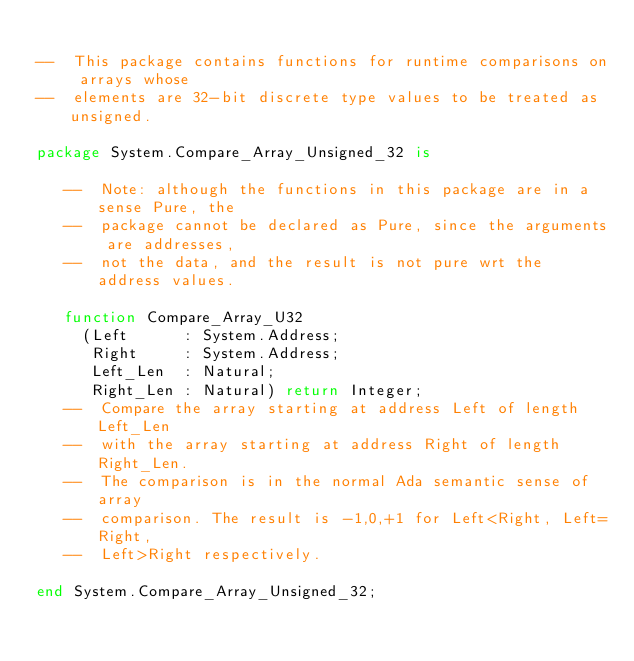<code> <loc_0><loc_0><loc_500><loc_500><_Ada_>
--  This package contains functions for runtime comparisons on arrays whose
--  elements are 32-bit discrete type values to be treated as unsigned.

package System.Compare_Array_Unsigned_32 is

   --  Note: although the functions in this package are in a sense Pure, the
   --  package cannot be declared as Pure, since the arguments are addresses,
   --  not the data, and the result is not pure wrt the address values.

   function Compare_Array_U32
     (Left      : System.Address;
      Right     : System.Address;
      Left_Len  : Natural;
      Right_Len : Natural) return Integer;
   --  Compare the array starting at address Left of length Left_Len
   --  with the array starting at address Right of length Right_Len.
   --  The comparison is in the normal Ada semantic sense of array
   --  comparison. The result is -1,0,+1 for Left<Right, Left=Right,
   --  Left>Right respectively.

end System.Compare_Array_Unsigned_32;
</code> 